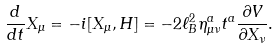Convert formula to latex. <formula><loc_0><loc_0><loc_500><loc_500>\frac { d } { d t } X _ { \mu } = - i [ X _ { \mu } , H ] = - 2 \ell ^ { 2 } _ { B } \eta _ { \mu \nu } ^ { a } t ^ { a } \frac { \partial V } { \partial X _ { \nu } } .</formula> 